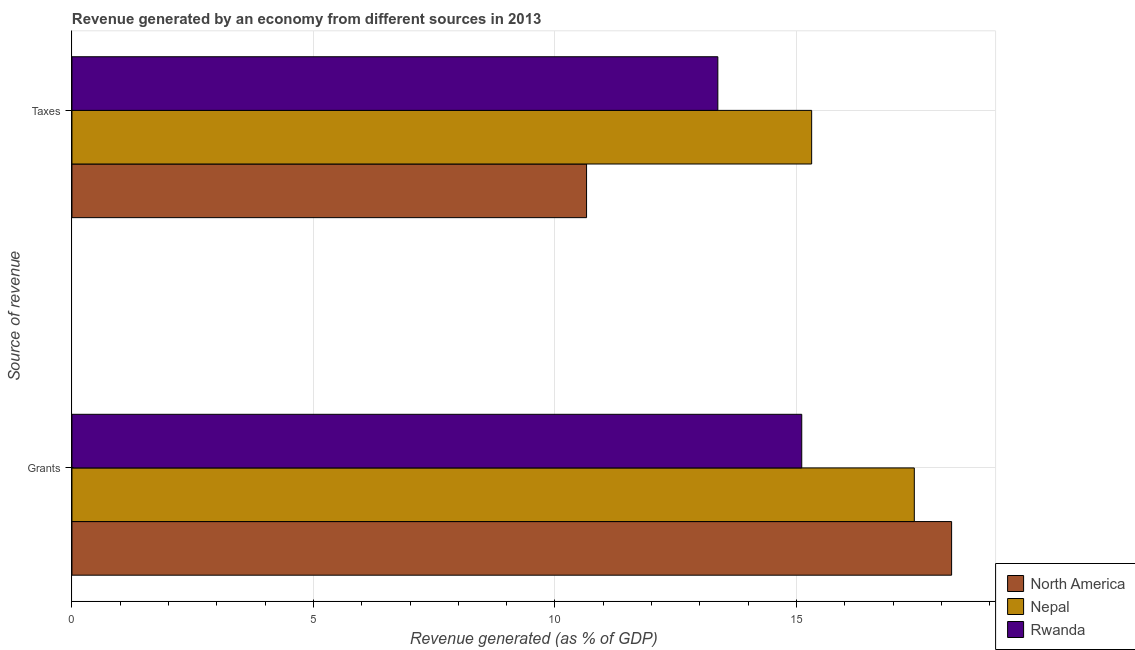How many different coloured bars are there?
Give a very brief answer. 3. How many groups of bars are there?
Give a very brief answer. 2. Are the number of bars on each tick of the Y-axis equal?
Keep it short and to the point. Yes. How many bars are there on the 2nd tick from the bottom?
Your answer should be very brief. 3. What is the label of the 1st group of bars from the top?
Your answer should be compact. Taxes. What is the revenue generated by grants in Nepal?
Provide a succinct answer. 17.44. Across all countries, what is the maximum revenue generated by taxes?
Offer a very short reply. 15.31. Across all countries, what is the minimum revenue generated by grants?
Offer a terse response. 15.11. In which country was the revenue generated by grants maximum?
Provide a short and direct response. North America. In which country was the revenue generated by grants minimum?
Ensure brevity in your answer.  Rwanda. What is the total revenue generated by grants in the graph?
Give a very brief answer. 50.76. What is the difference between the revenue generated by grants in Nepal and that in North America?
Ensure brevity in your answer.  -0.77. What is the difference between the revenue generated by grants in North America and the revenue generated by taxes in Nepal?
Provide a short and direct response. 2.9. What is the average revenue generated by grants per country?
Make the answer very short. 16.92. What is the difference between the revenue generated by taxes and revenue generated by grants in Nepal?
Offer a terse response. -2.13. What is the ratio of the revenue generated by taxes in Rwanda to that in North America?
Provide a succinct answer. 1.26. Is the revenue generated by taxes in North America less than that in Nepal?
Keep it short and to the point. Yes. In how many countries, is the revenue generated by taxes greater than the average revenue generated by taxes taken over all countries?
Your response must be concise. 2. What does the 2nd bar from the top in Grants represents?
Provide a short and direct response. Nepal. What does the 2nd bar from the bottom in Taxes represents?
Your answer should be compact. Nepal. Are all the bars in the graph horizontal?
Offer a very short reply. Yes. What is the difference between two consecutive major ticks on the X-axis?
Your answer should be very brief. 5. Are the values on the major ticks of X-axis written in scientific E-notation?
Make the answer very short. No. Does the graph contain grids?
Give a very brief answer. Yes. Where does the legend appear in the graph?
Ensure brevity in your answer.  Bottom right. How are the legend labels stacked?
Ensure brevity in your answer.  Vertical. What is the title of the graph?
Provide a short and direct response. Revenue generated by an economy from different sources in 2013. Does "Bermuda" appear as one of the legend labels in the graph?
Keep it short and to the point. No. What is the label or title of the X-axis?
Offer a very short reply. Revenue generated (as % of GDP). What is the label or title of the Y-axis?
Offer a terse response. Source of revenue. What is the Revenue generated (as % of GDP) of North America in Grants?
Your answer should be compact. 18.21. What is the Revenue generated (as % of GDP) of Nepal in Grants?
Your response must be concise. 17.44. What is the Revenue generated (as % of GDP) in Rwanda in Grants?
Offer a very short reply. 15.11. What is the Revenue generated (as % of GDP) in North America in Taxes?
Your response must be concise. 10.65. What is the Revenue generated (as % of GDP) in Nepal in Taxes?
Ensure brevity in your answer.  15.31. What is the Revenue generated (as % of GDP) in Rwanda in Taxes?
Your answer should be very brief. 13.37. Across all Source of revenue, what is the maximum Revenue generated (as % of GDP) in North America?
Provide a succinct answer. 18.21. Across all Source of revenue, what is the maximum Revenue generated (as % of GDP) of Nepal?
Ensure brevity in your answer.  17.44. Across all Source of revenue, what is the maximum Revenue generated (as % of GDP) of Rwanda?
Provide a succinct answer. 15.11. Across all Source of revenue, what is the minimum Revenue generated (as % of GDP) of North America?
Your answer should be very brief. 10.65. Across all Source of revenue, what is the minimum Revenue generated (as % of GDP) in Nepal?
Your response must be concise. 15.31. Across all Source of revenue, what is the minimum Revenue generated (as % of GDP) in Rwanda?
Provide a succinct answer. 13.37. What is the total Revenue generated (as % of GDP) of North America in the graph?
Offer a very short reply. 28.87. What is the total Revenue generated (as % of GDP) of Nepal in the graph?
Keep it short and to the point. 32.75. What is the total Revenue generated (as % of GDP) of Rwanda in the graph?
Offer a terse response. 28.48. What is the difference between the Revenue generated (as % of GDP) in North America in Grants and that in Taxes?
Your answer should be compact. 7.56. What is the difference between the Revenue generated (as % of GDP) in Nepal in Grants and that in Taxes?
Your answer should be compact. 2.13. What is the difference between the Revenue generated (as % of GDP) of Rwanda in Grants and that in Taxes?
Ensure brevity in your answer.  1.74. What is the difference between the Revenue generated (as % of GDP) in North America in Grants and the Revenue generated (as % of GDP) in Nepal in Taxes?
Ensure brevity in your answer.  2.9. What is the difference between the Revenue generated (as % of GDP) of North America in Grants and the Revenue generated (as % of GDP) of Rwanda in Taxes?
Ensure brevity in your answer.  4.84. What is the difference between the Revenue generated (as % of GDP) of Nepal in Grants and the Revenue generated (as % of GDP) of Rwanda in Taxes?
Your answer should be compact. 4.07. What is the average Revenue generated (as % of GDP) in North America per Source of revenue?
Your answer should be very brief. 14.43. What is the average Revenue generated (as % of GDP) of Nepal per Source of revenue?
Your answer should be compact. 16.38. What is the average Revenue generated (as % of GDP) in Rwanda per Source of revenue?
Your answer should be compact. 14.24. What is the difference between the Revenue generated (as % of GDP) of North America and Revenue generated (as % of GDP) of Nepal in Grants?
Make the answer very short. 0.77. What is the difference between the Revenue generated (as % of GDP) of North America and Revenue generated (as % of GDP) of Rwanda in Grants?
Provide a short and direct response. 3.1. What is the difference between the Revenue generated (as % of GDP) in Nepal and Revenue generated (as % of GDP) in Rwanda in Grants?
Provide a short and direct response. 2.33. What is the difference between the Revenue generated (as % of GDP) of North America and Revenue generated (as % of GDP) of Nepal in Taxes?
Offer a very short reply. -4.66. What is the difference between the Revenue generated (as % of GDP) in North America and Revenue generated (as % of GDP) in Rwanda in Taxes?
Keep it short and to the point. -2.72. What is the difference between the Revenue generated (as % of GDP) of Nepal and Revenue generated (as % of GDP) of Rwanda in Taxes?
Your response must be concise. 1.94. What is the ratio of the Revenue generated (as % of GDP) in North America in Grants to that in Taxes?
Ensure brevity in your answer.  1.71. What is the ratio of the Revenue generated (as % of GDP) of Nepal in Grants to that in Taxes?
Offer a terse response. 1.14. What is the ratio of the Revenue generated (as % of GDP) in Rwanda in Grants to that in Taxes?
Keep it short and to the point. 1.13. What is the difference between the highest and the second highest Revenue generated (as % of GDP) of North America?
Offer a very short reply. 7.56. What is the difference between the highest and the second highest Revenue generated (as % of GDP) of Nepal?
Give a very brief answer. 2.13. What is the difference between the highest and the second highest Revenue generated (as % of GDP) in Rwanda?
Provide a short and direct response. 1.74. What is the difference between the highest and the lowest Revenue generated (as % of GDP) in North America?
Offer a terse response. 7.56. What is the difference between the highest and the lowest Revenue generated (as % of GDP) in Nepal?
Your response must be concise. 2.13. What is the difference between the highest and the lowest Revenue generated (as % of GDP) of Rwanda?
Give a very brief answer. 1.74. 